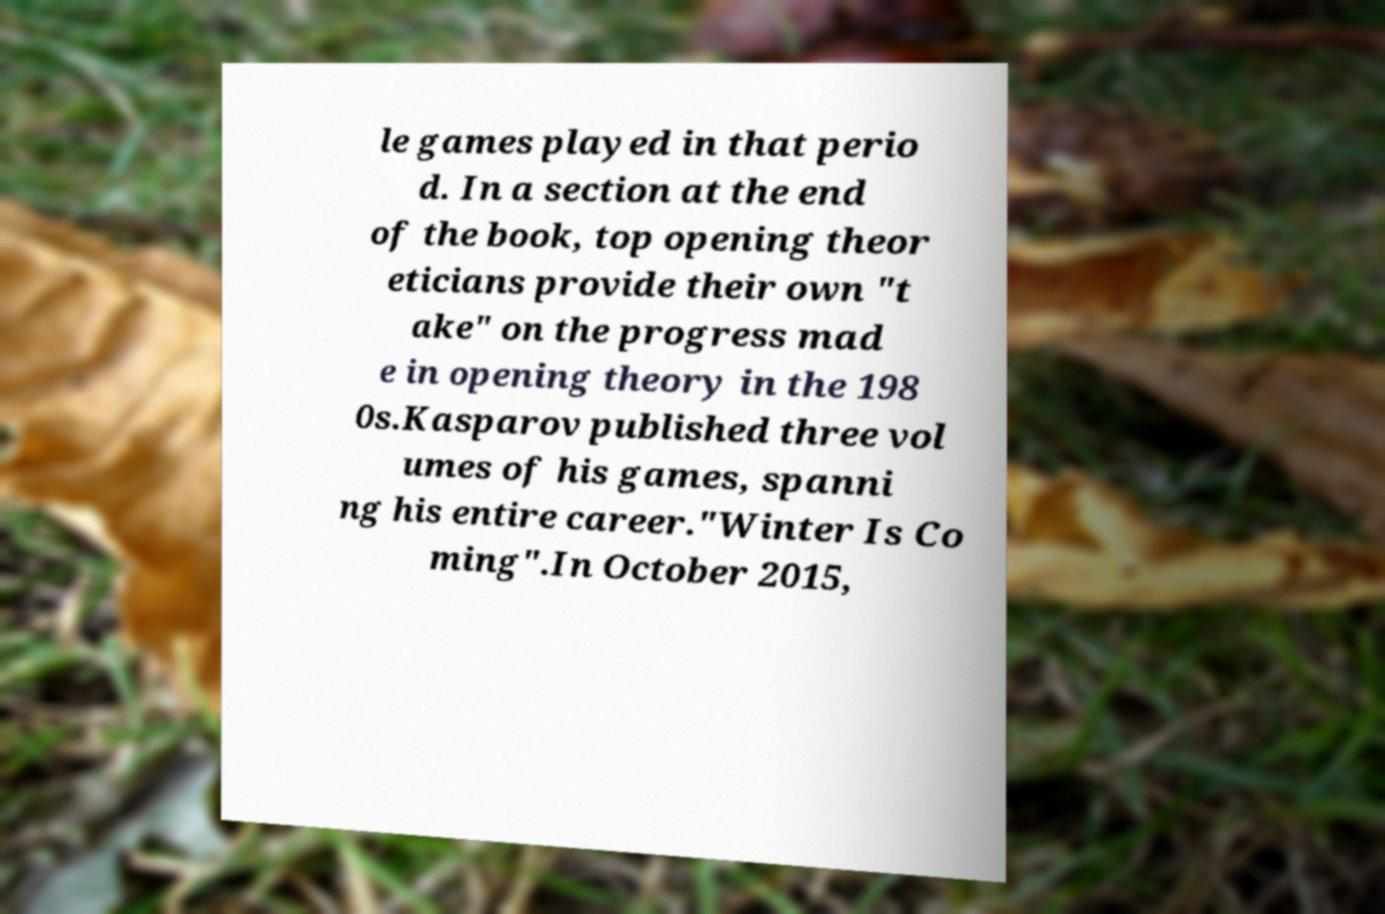What messages or text are displayed in this image? I need them in a readable, typed format. le games played in that perio d. In a section at the end of the book, top opening theor eticians provide their own "t ake" on the progress mad e in opening theory in the 198 0s.Kasparov published three vol umes of his games, spanni ng his entire career."Winter Is Co ming".In October 2015, 